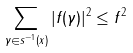Convert formula to latex. <formula><loc_0><loc_0><loc_500><loc_500>\sum _ { \gamma \in s ^ { - 1 } ( x ) } | f ( \gamma ) | ^ { 2 } \leq \| f \| ^ { 2 }</formula> 